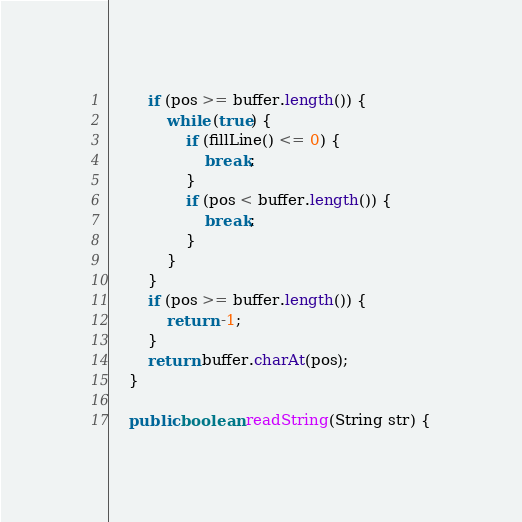<code> <loc_0><loc_0><loc_500><loc_500><_Java_>        if (pos >= buffer.length()) {
            while (true) {
                if (fillLine() <= 0) {
                    break;
                }
                if (pos < buffer.length()) {
                    break;
                }
            }
        }
        if (pos >= buffer.length()) {
            return -1;
        }
        return buffer.charAt(pos);
    }

    public boolean readString(String str) {</code> 